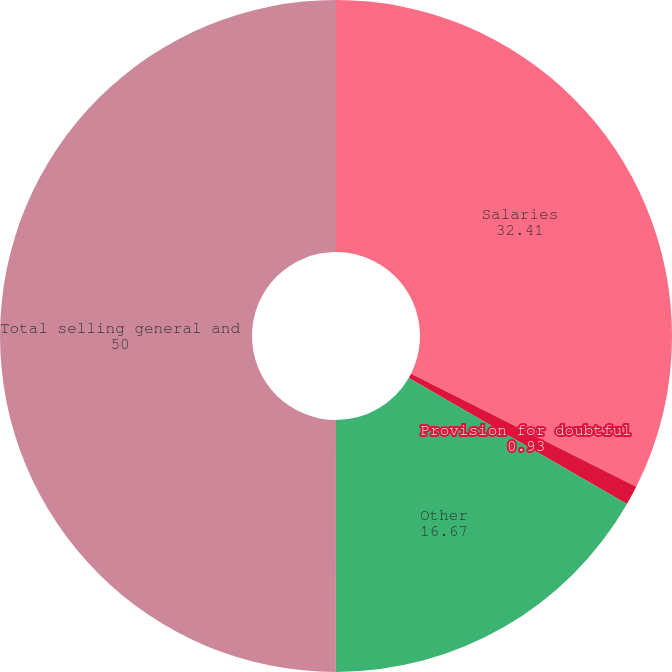Convert chart to OTSL. <chart><loc_0><loc_0><loc_500><loc_500><pie_chart><fcel>Salaries<fcel>Provision for doubtful<fcel>Other<fcel>Total selling general and<nl><fcel>32.41%<fcel>0.93%<fcel>16.67%<fcel>50.0%<nl></chart> 